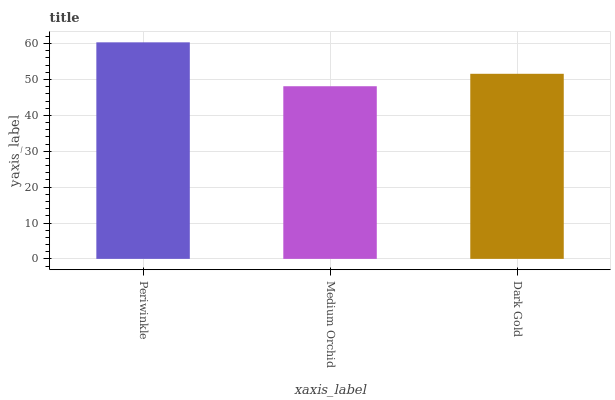Is Medium Orchid the minimum?
Answer yes or no. Yes. Is Periwinkle the maximum?
Answer yes or no. Yes. Is Dark Gold the minimum?
Answer yes or no. No. Is Dark Gold the maximum?
Answer yes or no. No. Is Dark Gold greater than Medium Orchid?
Answer yes or no. Yes. Is Medium Orchid less than Dark Gold?
Answer yes or no. Yes. Is Medium Orchid greater than Dark Gold?
Answer yes or no. No. Is Dark Gold less than Medium Orchid?
Answer yes or no. No. Is Dark Gold the high median?
Answer yes or no. Yes. Is Dark Gold the low median?
Answer yes or no. Yes. Is Medium Orchid the high median?
Answer yes or no. No. Is Medium Orchid the low median?
Answer yes or no. No. 